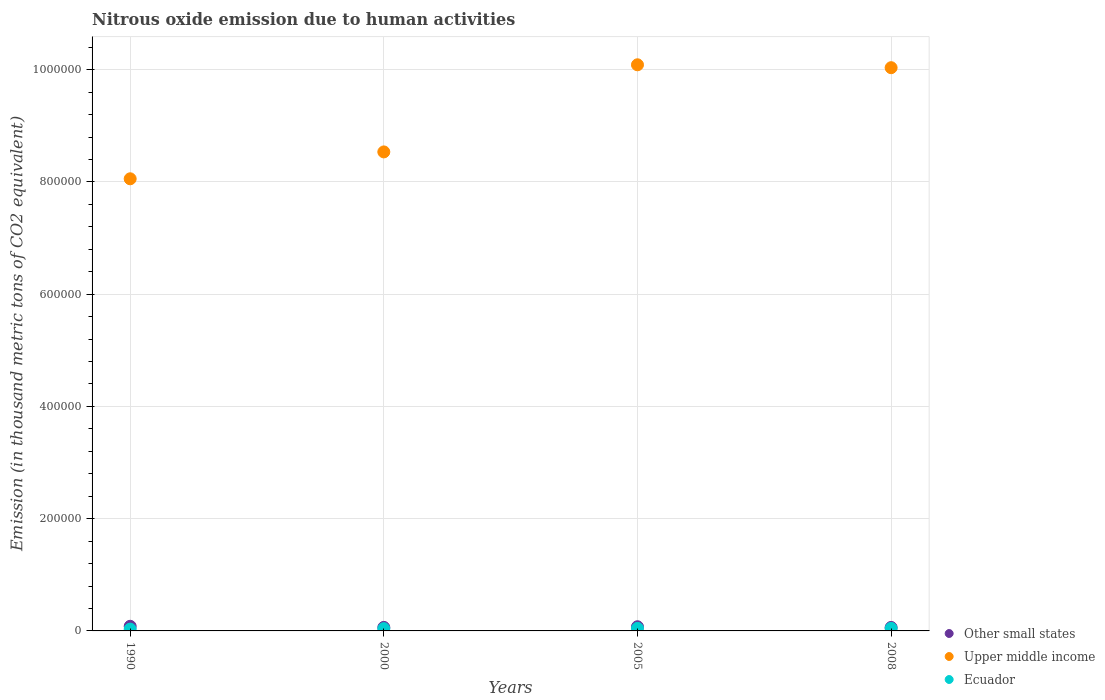What is the amount of nitrous oxide emitted in Ecuador in 1990?
Provide a succinct answer. 3194. Across all years, what is the maximum amount of nitrous oxide emitted in Upper middle income?
Offer a very short reply. 1.01e+06. Across all years, what is the minimum amount of nitrous oxide emitted in Ecuador?
Your response must be concise. 3194. In which year was the amount of nitrous oxide emitted in Other small states minimum?
Provide a short and direct response. 2008. What is the total amount of nitrous oxide emitted in Ecuador in the graph?
Your answer should be very brief. 1.63e+04. What is the difference between the amount of nitrous oxide emitted in Ecuador in 2005 and that in 2008?
Keep it short and to the point. 70.4. What is the difference between the amount of nitrous oxide emitted in Other small states in 1990 and the amount of nitrous oxide emitted in Ecuador in 2008?
Provide a succinct answer. 3760.6. What is the average amount of nitrous oxide emitted in Other small states per year?
Your answer should be compact. 7049.95. In the year 2005, what is the difference between the amount of nitrous oxide emitted in Upper middle income and amount of nitrous oxide emitted in Ecuador?
Your response must be concise. 1.00e+06. In how many years, is the amount of nitrous oxide emitted in Upper middle income greater than 160000 thousand metric tons?
Keep it short and to the point. 4. What is the ratio of the amount of nitrous oxide emitted in Upper middle income in 2005 to that in 2008?
Your response must be concise. 1.01. What is the difference between the highest and the second highest amount of nitrous oxide emitted in Ecuador?
Give a very brief answer. 70.4. What is the difference between the highest and the lowest amount of nitrous oxide emitted in Upper middle income?
Your response must be concise. 2.03e+05. In how many years, is the amount of nitrous oxide emitted in Other small states greater than the average amount of nitrous oxide emitted in Other small states taken over all years?
Make the answer very short. 2. Is it the case that in every year, the sum of the amount of nitrous oxide emitted in Ecuador and amount of nitrous oxide emitted in Other small states  is greater than the amount of nitrous oxide emitted in Upper middle income?
Your answer should be compact. No. Does the amount of nitrous oxide emitted in Other small states monotonically increase over the years?
Provide a succinct answer. No. Is the amount of nitrous oxide emitted in Ecuador strictly greater than the amount of nitrous oxide emitted in Upper middle income over the years?
Make the answer very short. No. How many dotlines are there?
Offer a terse response. 3. Does the graph contain grids?
Your answer should be compact. Yes. Where does the legend appear in the graph?
Your response must be concise. Bottom right. How many legend labels are there?
Your response must be concise. 3. What is the title of the graph?
Offer a very short reply. Nitrous oxide emission due to human activities. What is the label or title of the X-axis?
Your answer should be very brief. Years. What is the label or title of the Y-axis?
Give a very brief answer. Emission (in thousand metric tons of CO2 equivalent). What is the Emission (in thousand metric tons of CO2 equivalent) in Other small states in 1990?
Provide a short and direct response. 8248.7. What is the Emission (in thousand metric tons of CO2 equivalent) in Upper middle income in 1990?
Your answer should be compact. 8.06e+05. What is the Emission (in thousand metric tons of CO2 equivalent) of Ecuador in 1990?
Keep it short and to the point. 3194. What is the Emission (in thousand metric tons of CO2 equivalent) of Other small states in 2000?
Make the answer very short. 6297. What is the Emission (in thousand metric tons of CO2 equivalent) in Upper middle income in 2000?
Offer a very short reply. 8.54e+05. What is the Emission (in thousand metric tons of CO2 equivalent) in Ecuador in 2000?
Your answer should be very brief. 4067.7. What is the Emission (in thousand metric tons of CO2 equivalent) in Other small states in 2005?
Keep it short and to the point. 7434.8. What is the Emission (in thousand metric tons of CO2 equivalent) in Upper middle income in 2005?
Provide a succinct answer. 1.01e+06. What is the Emission (in thousand metric tons of CO2 equivalent) of Ecuador in 2005?
Your response must be concise. 4558.5. What is the Emission (in thousand metric tons of CO2 equivalent) of Other small states in 2008?
Your answer should be compact. 6219.3. What is the Emission (in thousand metric tons of CO2 equivalent) of Upper middle income in 2008?
Keep it short and to the point. 1.00e+06. What is the Emission (in thousand metric tons of CO2 equivalent) of Ecuador in 2008?
Keep it short and to the point. 4488.1. Across all years, what is the maximum Emission (in thousand metric tons of CO2 equivalent) of Other small states?
Provide a succinct answer. 8248.7. Across all years, what is the maximum Emission (in thousand metric tons of CO2 equivalent) of Upper middle income?
Your answer should be very brief. 1.01e+06. Across all years, what is the maximum Emission (in thousand metric tons of CO2 equivalent) in Ecuador?
Ensure brevity in your answer.  4558.5. Across all years, what is the minimum Emission (in thousand metric tons of CO2 equivalent) of Other small states?
Your answer should be compact. 6219.3. Across all years, what is the minimum Emission (in thousand metric tons of CO2 equivalent) of Upper middle income?
Ensure brevity in your answer.  8.06e+05. Across all years, what is the minimum Emission (in thousand metric tons of CO2 equivalent) in Ecuador?
Provide a succinct answer. 3194. What is the total Emission (in thousand metric tons of CO2 equivalent) in Other small states in the graph?
Keep it short and to the point. 2.82e+04. What is the total Emission (in thousand metric tons of CO2 equivalent) of Upper middle income in the graph?
Make the answer very short. 3.67e+06. What is the total Emission (in thousand metric tons of CO2 equivalent) in Ecuador in the graph?
Ensure brevity in your answer.  1.63e+04. What is the difference between the Emission (in thousand metric tons of CO2 equivalent) of Other small states in 1990 and that in 2000?
Your response must be concise. 1951.7. What is the difference between the Emission (in thousand metric tons of CO2 equivalent) of Upper middle income in 1990 and that in 2000?
Ensure brevity in your answer.  -4.79e+04. What is the difference between the Emission (in thousand metric tons of CO2 equivalent) in Ecuador in 1990 and that in 2000?
Ensure brevity in your answer.  -873.7. What is the difference between the Emission (in thousand metric tons of CO2 equivalent) of Other small states in 1990 and that in 2005?
Keep it short and to the point. 813.9. What is the difference between the Emission (in thousand metric tons of CO2 equivalent) in Upper middle income in 1990 and that in 2005?
Keep it short and to the point. -2.03e+05. What is the difference between the Emission (in thousand metric tons of CO2 equivalent) of Ecuador in 1990 and that in 2005?
Your answer should be very brief. -1364.5. What is the difference between the Emission (in thousand metric tons of CO2 equivalent) in Other small states in 1990 and that in 2008?
Keep it short and to the point. 2029.4. What is the difference between the Emission (in thousand metric tons of CO2 equivalent) of Upper middle income in 1990 and that in 2008?
Make the answer very short. -1.98e+05. What is the difference between the Emission (in thousand metric tons of CO2 equivalent) in Ecuador in 1990 and that in 2008?
Your response must be concise. -1294.1. What is the difference between the Emission (in thousand metric tons of CO2 equivalent) in Other small states in 2000 and that in 2005?
Provide a succinct answer. -1137.8. What is the difference between the Emission (in thousand metric tons of CO2 equivalent) in Upper middle income in 2000 and that in 2005?
Provide a short and direct response. -1.55e+05. What is the difference between the Emission (in thousand metric tons of CO2 equivalent) in Ecuador in 2000 and that in 2005?
Ensure brevity in your answer.  -490.8. What is the difference between the Emission (in thousand metric tons of CO2 equivalent) of Other small states in 2000 and that in 2008?
Your response must be concise. 77.7. What is the difference between the Emission (in thousand metric tons of CO2 equivalent) of Upper middle income in 2000 and that in 2008?
Make the answer very short. -1.50e+05. What is the difference between the Emission (in thousand metric tons of CO2 equivalent) of Ecuador in 2000 and that in 2008?
Provide a short and direct response. -420.4. What is the difference between the Emission (in thousand metric tons of CO2 equivalent) in Other small states in 2005 and that in 2008?
Keep it short and to the point. 1215.5. What is the difference between the Emission (in thousand metric tons of CO2 equivalent) of Upper middle income in 2005 and that in 2008?
Keep it short and to the point. 5159.9. What is the difference between the Emission (in thousand metric tons of CO2 equivalent) of Ecuador in 2005 and that in 2008?
Make the answer very short. 70.4. What is the difference between the Emission (in thousand metric tons of CO2 equivalent) in Other small states in 1990 and the Emission (in thousand metric tons of CO2 equivalent) in Upper middle income in 2000?
Ensure brevity in your answer.  -8.45e+05. What is the difference between the Emission (in thousand metric tons of CO2 equivalent) of Other small states in 1990 and the Emission (in thousand metric tons of CO2 equivalent) of Ecuador in 2000?
Provide a succinct answer. 4181. What is the difference between the Emission (in thousand metric tons of CO2 equivalent) of Upper middle income in 1990 and the Emission (in thousand metric tons of CO2 equivalent) of Ecuador in 2000?
Your answer should be very brief. 8.02e+05. What is the difference between the Emission (in thousand metric tons of CO2 equivalent) in Other small states in 1990 and the Emission (in thousand metric tons of CO2 equivalent) in Upper middle income in 2005?
Your answer should be very brief. -1.00e+06. What is the difference between the Emission (in thousand metric tons of CO2 equivalent) of Other small states in 1990 and the Emission (in thousand metric tons of CO2 equivalent) of Ecuador in 2005?
Your answer should be compact. 3690.2. What is the difference between the Emission (in thousand metric tons of CO2 equivalent) of Upper middle income in 1990 and the Emission (in thousand metric tons of CO2 equivalent) of Ecuador in 2005?
Your response must be concise. 8.01e+05. What is the difference between the Emission (in thousand metric tons of CO2 equivalent) of Other small states in 1990 and the Emission (in thousand metric tons of CO2 equivalent) of Upper middle income in 2008?
Your answer should be very brief. -9.95e+05. What is the difference between the Emission (in thousand metric tons of CO2 equivalent) of Other small states in 1990 and the Emission (in thousand metric tons of CO2 equivalent) of Ecuador in 2008?
Offer a terse response. 3760.6. What is the difference between the Emission (in thousand metric tons of CO2 equivalent) in Upper middle income in 1990 and the Emission (in thousand metric tons of CO2 equivalent) in Ecuador in 2008?
Your answer should be very brief. 8.01e+05. What is the difference between the Emission (in thousand metric tons of CO2 equivalent) in Other small states in 2000 and the Emission (in thousand metric tons of CO2 equivalent) in Upper middle income in 2005?
Ensure brevity in your answer.  -1.00e+06. What is the difference between the Emission (in thousand metric tons of CO2 equivalent) of Other small states in 2000 and the Emission (in thousand metric tons of CO2 equivalent) of Ecuador in 2005?
Provide a succinct answer. 1738.5. What is the difference between the Emission (in thousand metric tons of CO2 equivalent) in Upper middle income in 2000 and the Emission (in thousand metric tons of CO2 equivalent) in Ecuador in 2005?
Ensure brevity in your answer.  8.49e+05. What is the difference between the Emission (in thousand metric tons of CO2 equivalent) in Other small states in 2000 and the Emission (in thousand metric tons of CO2 equivalent) in Upper middle income in 2008?
Provide a short and direct response. -9.97e+05. What is the difference between the Emission (in thousand metric tons of CO2 equivalent) of Other small states in 2000 and the Emission (in thousand metric tons of CO2 equivalent) of Ecuador in 2008?
Provide a succinct answer. 1808.9. What is the difference between the Emission (in thousand metric tons of CO2 equivalent) of Upper middle income in 2000 and the Emission (in thousand metric tons of CO2 equivalent) of Ecuador in 2008?
Offer a very short reply. 8.49e+05. What is the difference between the Emission (in thousand metric tons of CO2 equivalent) of Other small states in 2005 and the Emission (in thousand metric tons of CO2 equivalent) of Upper middle income in 2008?
Provide a succinct answer. -9.96e+05. What is the difference between the Emission (in thousand metric tons of CO2 equivalent) of Other small states in 2005 and the Emission (in thousand metric tons of CO2 equivalent) of Ecuador in 2008?
Your response must be concise. 2946.7. What is the difference between the Emission (in thousand metric tons of CO2 equivalent) in Upper middle income in 2005 and the Emission (in thousand metric tons of CO2 equivalent) in Ecuador in 2008?
Make the answer very short. 1.00e+06. What is the average Emission (in thousand metric tons of CO2 equivalent) in Other small states per year?
Keep it short and to the point. 7049.95. What is the average Emission (in thousand metric tons of CO2 equivalent) of Upper middle income per year?
Your answer should be compact. 9.18e+05. What is the average Emission (in thousand metric tons of CO2 equivalent) in Ecuador per year?
Provide a short and direct response. 4077.07. In the year 1990, what is the difference between the Emission (in thousand metric tons of CO2 equivalent) in Other small states and Emission (in thousand metric tons of CO2 equivalent) in Upper middle income?
Give a very brief answer. -7.97e+05. In the year 1990, what is the difference between the Emission (in thousand metric tons of CO2 equivalent) of Other small states and Emission (in thousand metric tons of CO2 equivalent) of Ecuador?
Your answer should be compact. 5054.7. In the year 1990, what is the difference between the Emission (in thousand metric tons of CO2 equivalent) of Upper middle income and Emission (in thousand metric tons of CO2 equivalent) of Ecuador?
Give a very brief answer. 8.02e+05. In the year 2000, what is the difference between the Emission (in thousand metric tons of CO2 equivalent) of Other small states and Emission (in thousand metric tons of CO2 equivalent) of Upper middle income?
Keep it short and to the point. -8.47e+05. In the year 2000, what is the difference between the Emission (in thousand metric tons of CO2 equivalent) of Other small states and Emission (in thousand metric tons of CO2 equivalent) of Ecuador?
Your response must be concise. 2229.3. In the year 2000, what is the difference between the Emission (in thousand metric tons of CO2 equivalent) of Upper middle income and Emission (in thousand metric tons of CO2 equivalent) of Ecuador?
Provide a succinct answer. 8.49e+05. In the year 2005, what is the difference between the Emission (in thousand metric tons of CO2 equivalent) of Other small states and Emission (in thousand metric tons of CO2 equivalent) of Upper middle income?
Your answer should be compact. -1.00e+06. In the year 2005, what is the difference between the Emission (in thousand metric tons of CO2 equivalent) of Other small states and Emission (in thousand metric tons of CO2 equivalent) of Ecuador?
Make the answer very short. 2876.3. In the year 2005, what is the difference between the Emission (in thousand metric tons of CO2 equivalent) in Upper middle income and Emission (in thousand metric tons of CO2 equivalent) in Ecuador?
Offer a very short reply. 1.00e+06. In the year 2008, what is the difference between the Emission (in thousand metric tons of CO2 equivalent) in Other small states and Emission (in thousand metric tons of CO2 equivalent) in Upper middle income?
Your response must be concise. -9.97e+05. In the year 2008, what is the difference between the Emission (in thousand metric tons of CO2 equivalent) of Other small states and Emission (in thousand metric tons of CO2 equivalent) of Ecuador?
Your answer should be compact. 1731.2. In the year 2008, what is the difference between the Emission (in thousand metric tons of CO2 equivalent) in Upper middle income and Emission (in thousand metric tons of CO2 equivalent) in Ecuador?
Give a very brief answer. 9.99e+05. What is the ratio of the Emission (in thousand metric tons of CO2 equivalent) in Other small states in 1990 to that in 2000?
Your answer should be compact. 1.31. What is the ratio of the Emission (in thousand metric tons of CO2 equivalent) in Upper middle income in 1990 to that in 2000?
Provide a succinct answer. 0.94. What is the ratio of the Emission (in thousand metric tons of CO2 equivalent) of Ecuador in 1990 to that in 2000?
Offer a terse response. 0.79. What is the ratio of the Emission (in thousand metric tons of CO2 equivalent) of Other small states in 1990 to that in 2005?
Provide a succinct answer. 1.11. What is the ratio of the Emission (in thousand metric tons of CO2 equivalent) in Upper middle income in 1990 to that in 2005?
Your answer should be compact. 0.8. What is the ratio of the Emission (in thousand metric tons of CO2 equivalent) in Ecuador in 1990 to that in 2005?
Offer a very short reply. 0.7. What is the ratio of the Emission (in thousand metric tons of CO2 equivalent) in Other small states in 1990 to that in 2008?
Make the answer very short. 1.33. What is the ratio of the Emission (in thousand metric tons of CO2 equivalent) in Upper middle income in 1990 to that in 2008?
Make the answer very short. 0.8. What is the ratio of the Emission (in thousand metric tons of CO2 equivalent) in Ecuador in 1990 to that in 2008?
Give a very brief answer. 0.71. What is the ratio of the Emission (in thousand metric tons of CO2 equivalent) of Other small states in 2000 to that in 2005?
Your response must be concise. 0.85. What is the ratio of the Emission (in thousand metric tons of CO2 equivalent) in Upper middle income in 2000 to that in 2005?
Provide a succinct answer. 0.85. What is the ratio of the Emission (in thousand metric tons of CO2 equivalent) of Ecuador in 2000 to that in 2005?
Offer a very short reply. 0.89. What is the ratio of the Emission (in thousand metric tons of CO2 equivalent) in Other small states in 2000 to that in 2008?
Provide a succinct answer. 1.01. What is the ratio of the Emission (in thousand metric tons of CO2 equivalent) of Upper middle income in 2000 to that in 2008?
Make the answer very short. 0.85. What is the ratio of the Emission (in thousand metric tons of CO2 equivalent) of Ecuador in 2000 to that in 2008?
Ensure brevity in your answer.  0.91. What is the ratio of the Emission (in thousand metric tons of CO2 equivalent) of Other small states in 2005 to that in 2008?
Offer a terse response. 1.2. What is the ratio of the Emission (in thousand metric tons of CO2 equivalent) in Upper middle income in 2005 to that in 2008?
Provide a succinct answer. 1.01. What is the ratio of the Emission (in thousand metric tons of CO2 equivalent) in Ecuador in 2005 to that in 2008?
Provide a succinct answer. 1.02. What is the difference between the highest and the second highest Emission (in thousand metric tons of CO2 equivalent) in Other small states?
Make the answer very short. 813.9. What is the difference between the highest and the second highest Emission (in thousand metric tons of CO2 equivalent) of Upper middle income?
Provide a short and direct response. 5159.9. What is the difference between the highest and the second highest Emission (in thousand metric tons of CO2 equivalent) of Ecuador?
Your response must be concise. 70.4. What is the difference between the highest and the lowest Emission (in thousand metric tons of CO2 equivalent) in Other small states?
Give a very brief answer. 2029.4. What is the difference between the highest and the lowest Emission (in thousand metric tons of CO2 equivalent) of Upper middle income?
Ensure brevity in your answer.  2.03e+05. What is the difference between the highest and the lowest Emission (in thousand metric tons of CO2 equivalent) in Ecuador?
Offer a very short reply. 1364.5. 